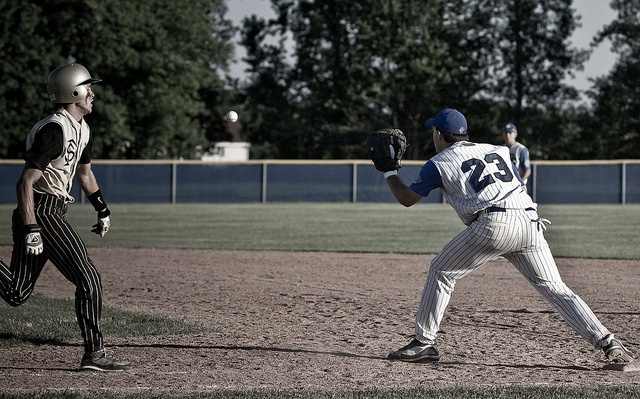Describe the objects in this image and their specific colors. I can see people in black, gray, white, and darkgray tones, people in black, gray, darkgray, and lightgray tones, baseball glove in black, gray, and darkgray tones, people in black, darkgray, gray, and lightgray tones, and sports ball in black, white, gray, and darkgray tones in this image. 